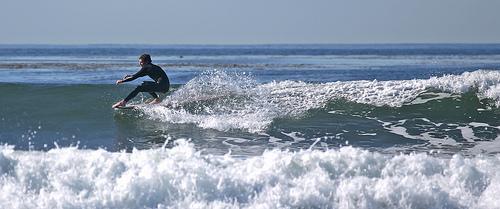How many people are shown?
Give a very brief answer. 1. 